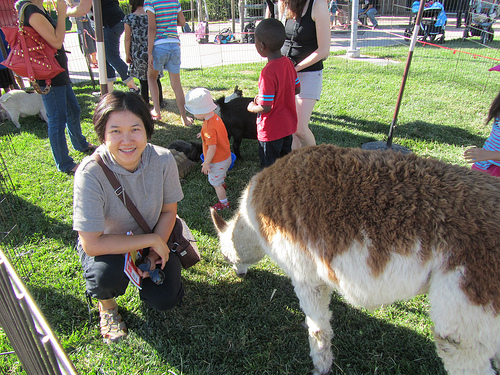Describe what the children are doing. The children in the image appear to be engaged with the animals in what seems to be a petting zoo. They are interacting closely, with the boy in the red shirt reaching out towards one of the animals, and another child nearby observing the scene intently. Explain the setting of this image in detail. The setting of the image is an outdoor petting zoo, likely in a park or a specific area designated for animal interaction. The area is fenced off to create a safe space for both the animals and visitors. The grass is lush and green, indicating a well-maintained environment. In the background, there are other people and children, suggesting a lively, family-friendly atmosphere. The petting zoo seems to be a highlight, drawing the children's attention as they enthusiastically engage with the animals. What might these children be thinking while interacting with the animals? The children might be thinking about how exciting it is to be close to the animals, feeling a mix of curiosity and joy. They could be wondering about the different types of animals they see, how they feel when petting them, or simply enjoying the opportunity to be in a fun and relaxed environment. Some might be thinking about their favorite animals and this unique chance to interact with them closely. Create a whimsical story inspired by the petting zoo scene. Once upon a time, in the magical gardens of Quacksalot Park, there existed a petting zoo unlike any other. Here, the animals were not just animals, but enchanted creatures from a forgotten era. The llama, Sir Fluffington, could speak in riddles and share ancient tales, while the sheep, Princess Woolamina, had a wool coat that shimmered with the colors of the rainbow. Every child who stepped into this enchanted petting zoo was gifted with profound wisdom from these magical beings. On a bright and sunny day, young Benji and his friends ventured into this wonderland. As they fed the animals and patted their soft coats, Sir Fluffington whispered secrets of the forest and how to summon a unicorn, while Princess Woolamina wove a scarf of light, gifting it to Benji for his bravery. It was a day they would cherish forever, filled with magic, laughter, and bonds that would last a lifetime. Imagine how this day at the zoo can lead to a lifelong interest in animal care. For many children, a day spent at a petting zoo can spark a lifelong passion for animals and their care. The unique experience of being able to touch, feed, and interact with animals can lead to a deeper appreciation and respect for wildlife. Children like Benji, who feel a special connection with the animals, might grow into empathetic adults who pursue careers in veterinary medicine, animal rescue, wildlife conservation, or even zoology. They may join clubs or volunteer at local shelters, constantly seeking ways to be near animals and take care of them. This formative experience at the petting zoo ignites a spark that can lead to a fulfilling and meaningful lifelong journey dedicated to animal wellbeing. 